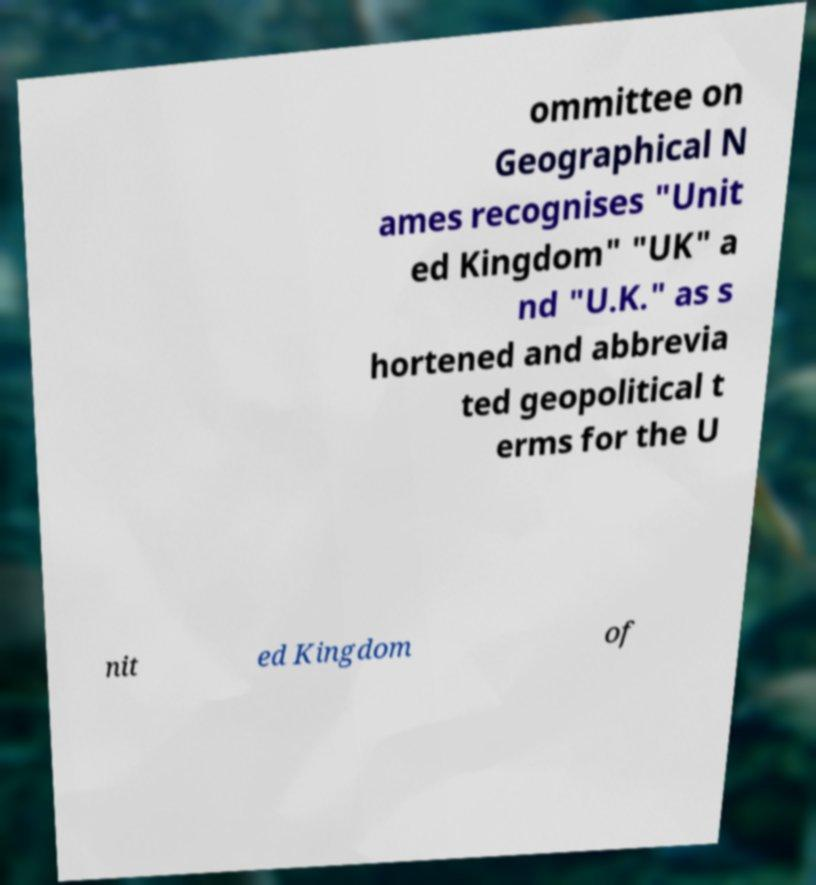Can you read and provide the text displayed in the image?This photo seems to have some interesting text. Can you extract and type it out for me? ommittee on Geographical N ames recognises "Unit ed Kingdom" "UK" a nd "U.K." as s hortened and abbrevia ted geopolitical t erms for the U nit ed Kingdom of 